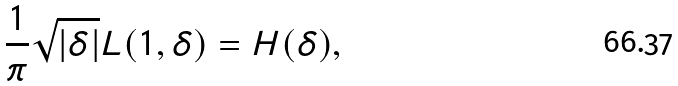<formula> <loc_0><loc_0><loc_500><loc_500>\frac { 1 } { \pi } \sqrt { | \delta | } L ( 1 , \delta ) = H ( \delta ) ,</formula> 